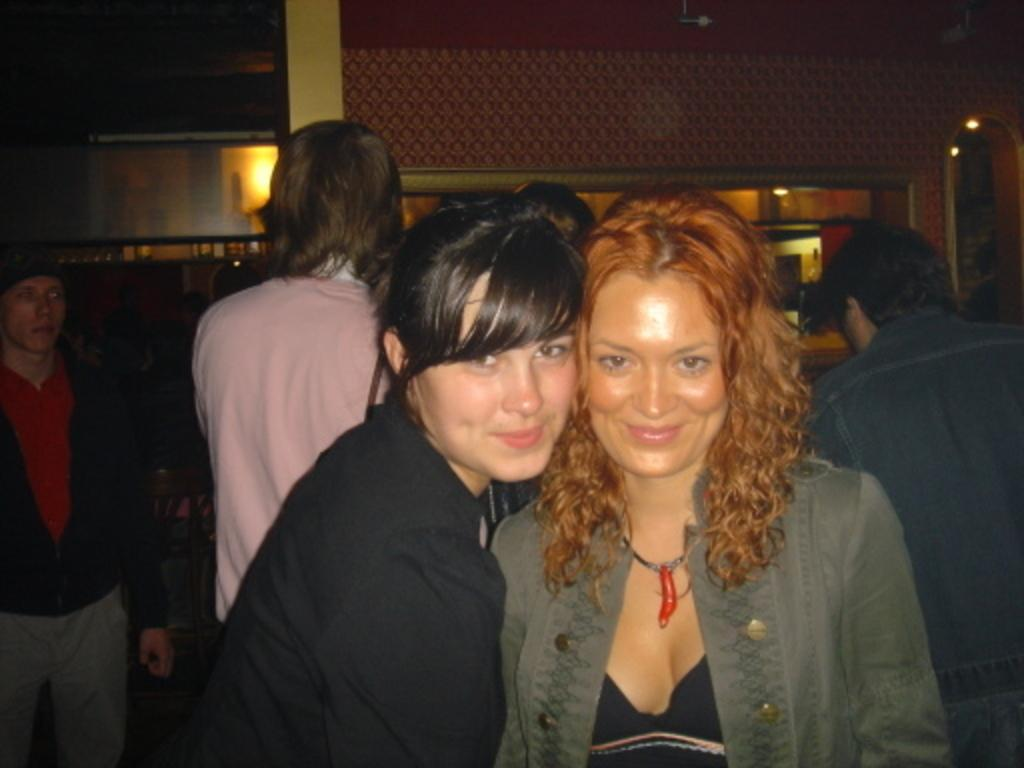How many women are in the image? There are two women in the image. What are the women doing in the image? The women are standing in the image. What expression do the women have in the image? The women are smiling in the image. What is visible in the background of the image? There is a wall in the image. How many people are standing in the image? There are a few people standing in the image. What type of religious control is being exercised by the women in the image? There is no indication of any religious control being exercised by the women in the image. What type of school can be seen in the image? There is no school present in the image. 